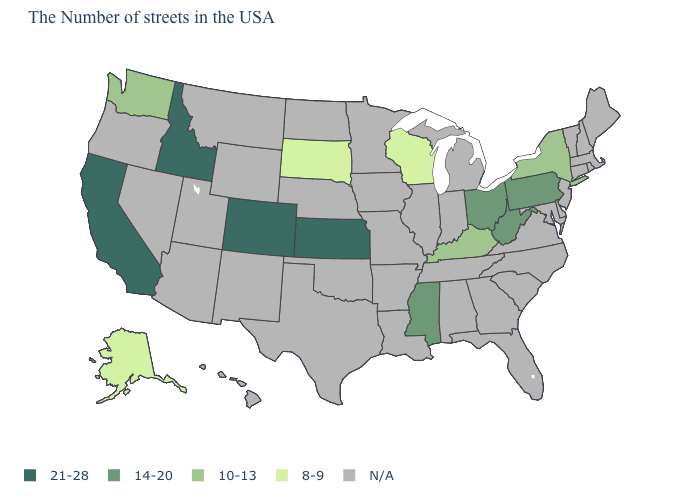Name the states that have a value in the range N/A?
Answer briefly. Maine, Massachusetts, Rhode Island, New Hampshire, Vermont, Connecticut, New Jersey, Delaware, Maryland, Virginia, North Carolina, South Carolina, Florida, Georgia, Michigan, Indiana, Alabama, Tennessee, Illinois, Louisiana, Missouri, Arkansas, Minnesota, Iowa, Nebraska, Oklahoma, Texas, North Dakota, Wyoming, New Mexico, Utah, Montana, Arizona, Nevada, Oregon, Hawaii. Name the states that have a value in the range 8-9?
Keep it brief. Wisconsin, South Dakota, Alaska. What is the value of Delaware?
Quick response, please. N/A. What is the value of Ohio?
Write a very short answer. 14-20. Name the states that have a value in the range 14-20?
Be succinct. Pennsylvania, West Virginia, Ohio, Mississippi. Does Alaska have the lowest value in the West?
Be succinct. Yes. What is the highest value in the USA?
Short answer required. 21-28. Does the first symbol in the legend represent the smallest category?
Short answer required. No. What is the lowest value in states that border Ohio?
Write a very short answer. 10-13. What is the value of Illinois?
Be succinct. N/A. What is the value of Vermont?
Be succinct. N/A. How many symbols are there in the legend?
Be succinct. 5. Among the states that border Nevada , which have the lowest value?
Be succinct. Idaho, California. What is the value of Massachusetts?
Write a very short answer. N/A. 